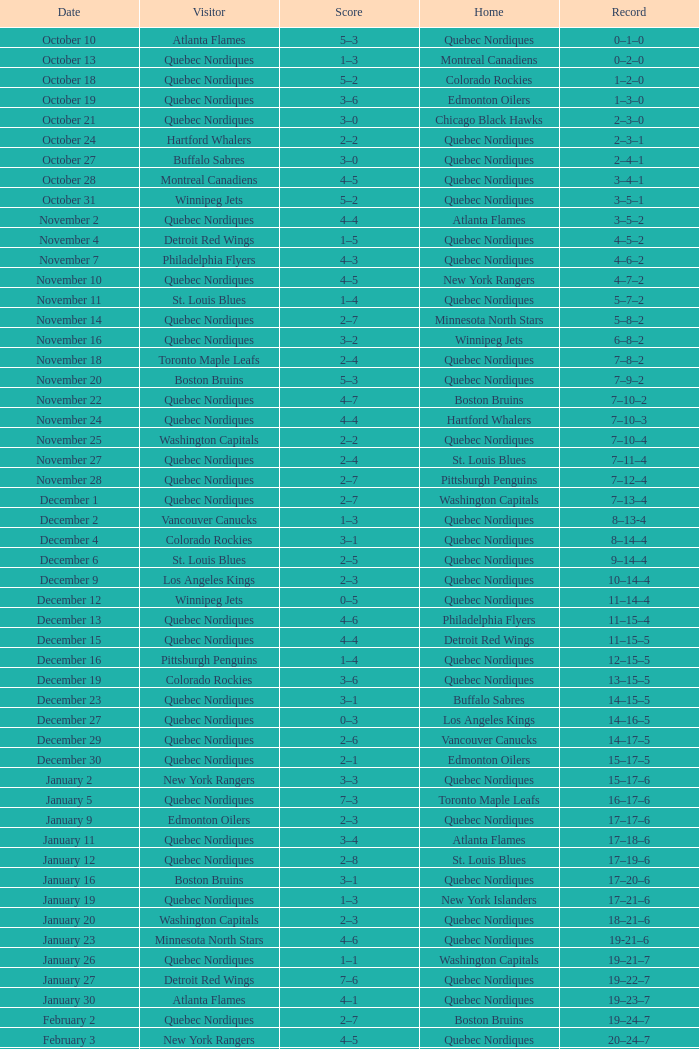Which house has a record of 11-14-4? Quebec Nordiques. 